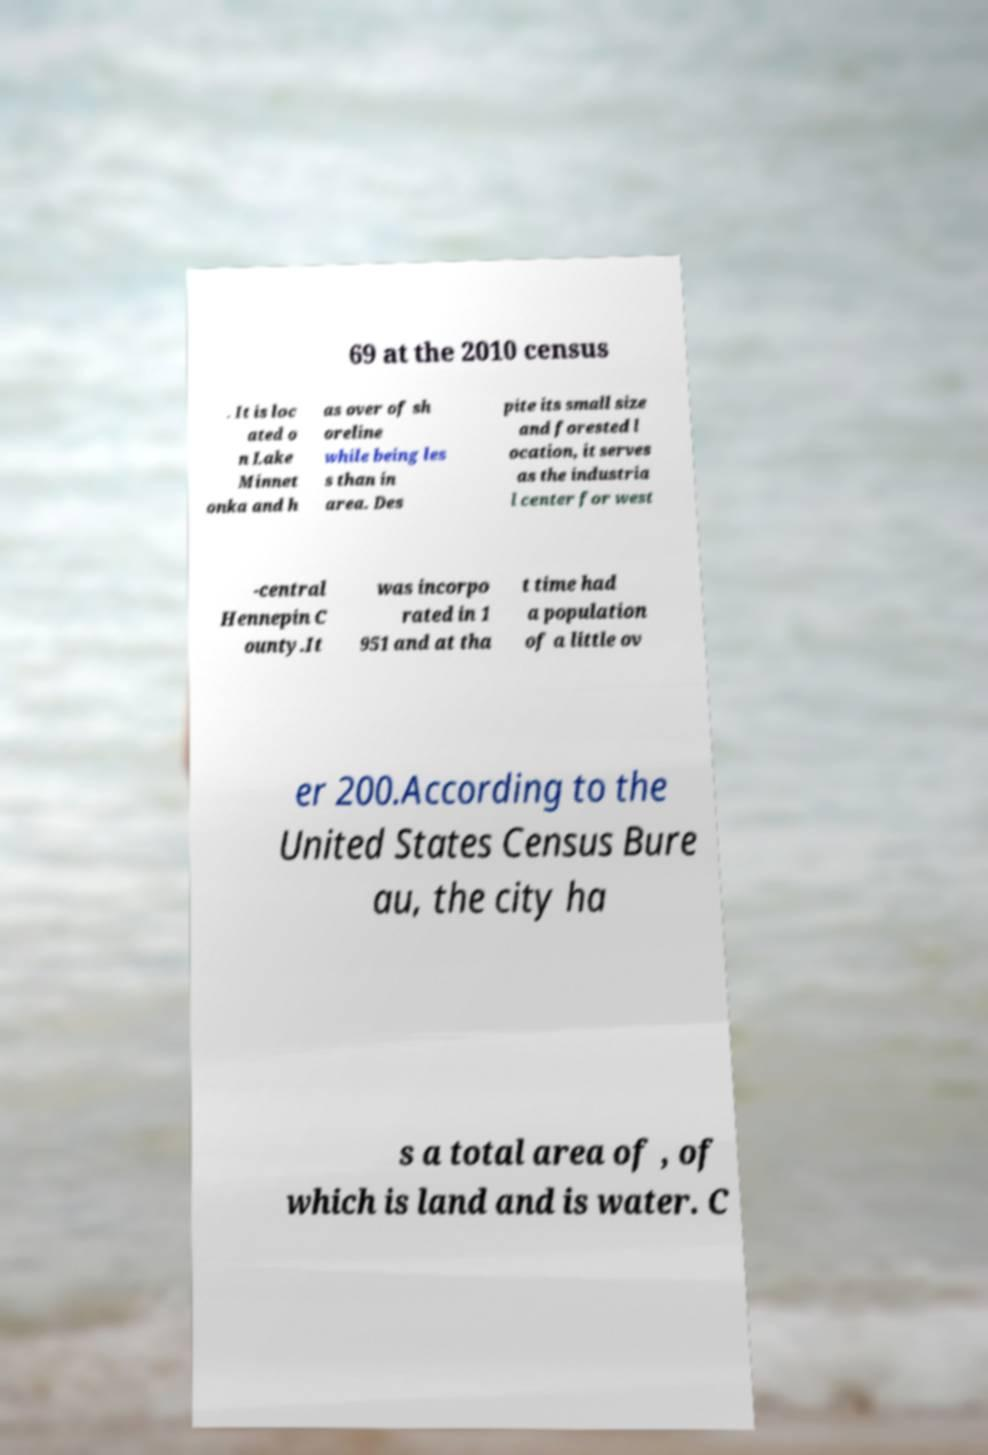Can you read and provide the text displayed in the image?This photo seems to have some interesting text. Can you extract and type it out for me? 69 at the 2010 census . It is loc ated o n Lake Minnet onka and h as over of sh oreline while being les s than in area. Des pite its small size and forested l ocation, it serves as the industria l center for west -central Hennepin C ounty.It was incorpo rated in 1 951 and at tha t time had a population of a little ov er 200.According to the United States Census Bure au, the city ha s a total area of , of which is land and is water. C 